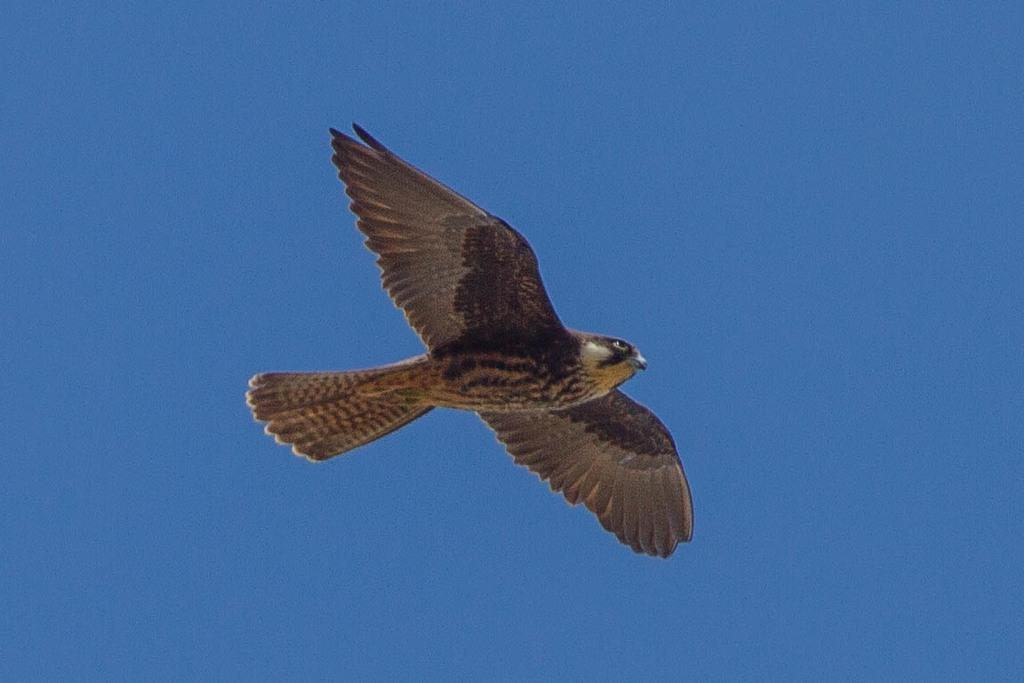What type of animal is present in the image? There is a bird in the image. What is the bird doing in the image? The bird is flying in the air. What can be seen in the background of the image? The sky is visible in the background of the image. What is the color of the sky in the image? The color of the sky is blue. What type of fuel does the bird use to fly in the image? Birds do not use fuel to fly; they use their wings and muscles to propel themselves through the air. 